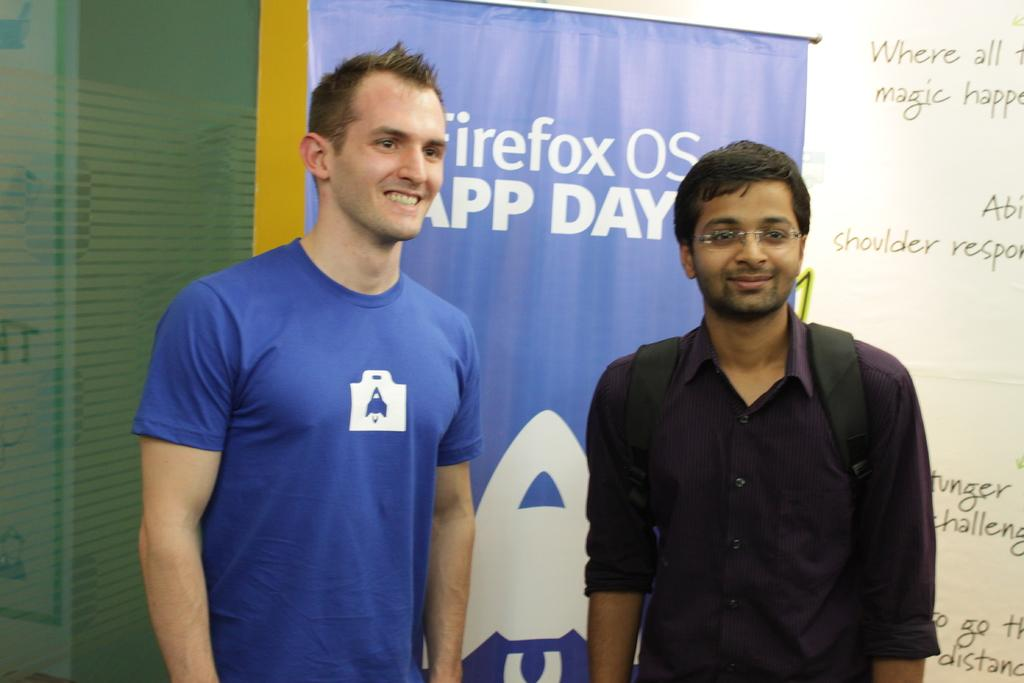<image>
Provide a brief description of the given image. The men are standing by a poster promoting the Firefox OS app. 